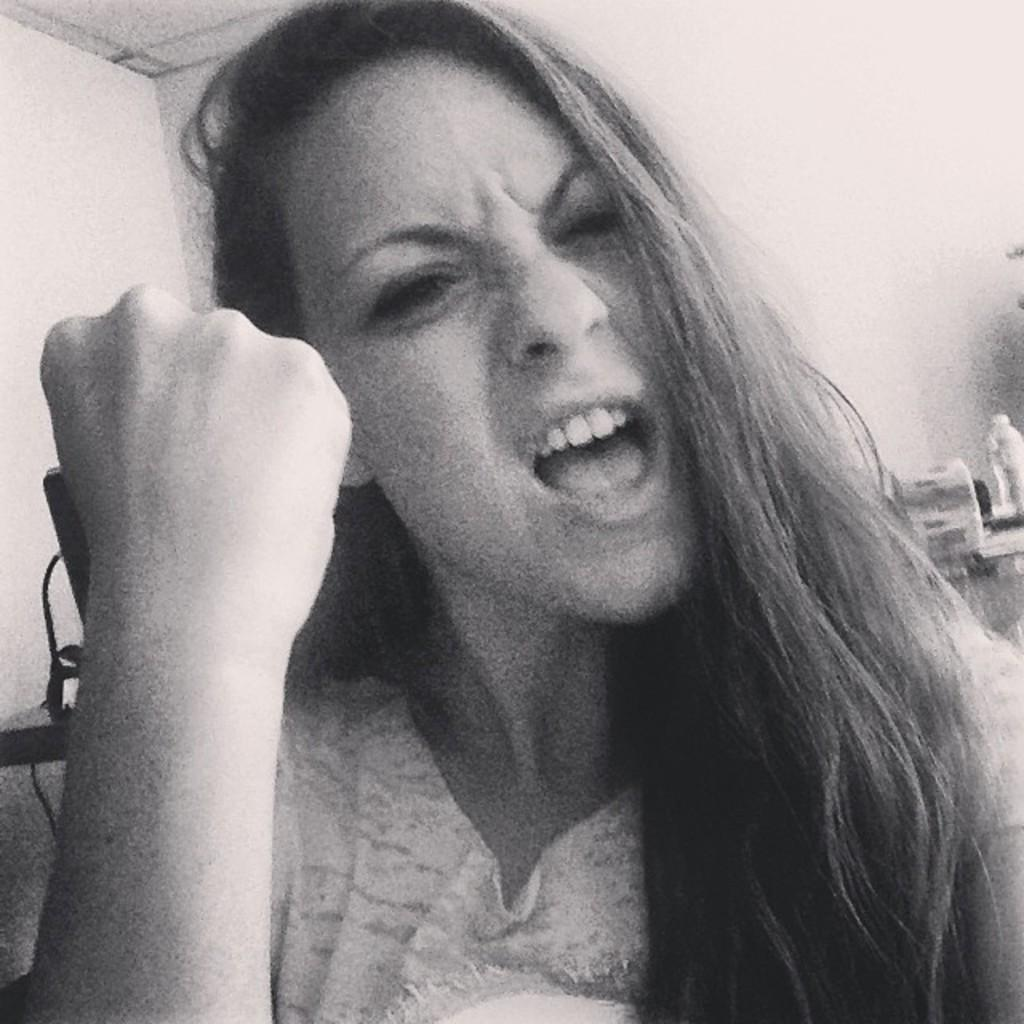Who is the main subject in the image? There is a woman in the image. What is the woman doing with her mouth? The woman has her mouth open. What action is the woman taking with her hand? The woman is shaking her fist. Can you describe the objects behind the woman? Unfortunately, the facts provided do not specify the nature of the objects behind the woman. What is the value of the doll in the image? There is no doll present in the image, so it is not possible to determine its value. 